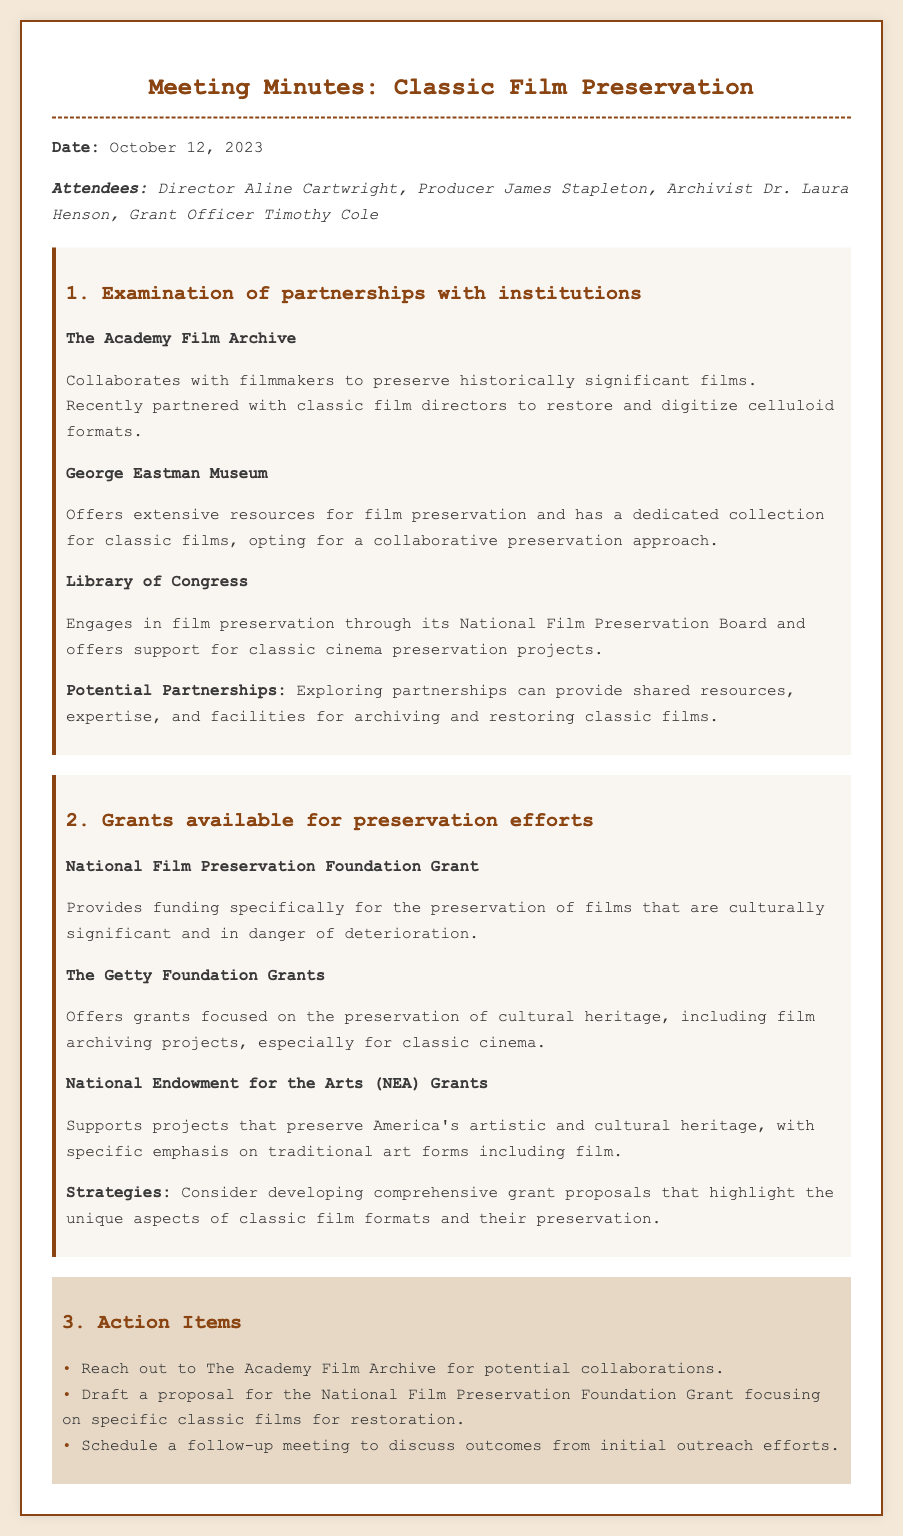What is the date of the meeting? The date of the meeting is specified at the top of the document.
Answer: October 12, 2023 Who is the archivist present at the meeting? The names of attendees are listed in the document, including their roles.
Answer: Dr. Laura Henson What institution collaborates with filmmakers to preserve historically significant films? This information is under the examination of partnerships with institutions section.
Answer: The Academy Film Archive What grant provides funding for the preservation of culturally significant films? The grants available for preservation efforts section lists various grants focused on preservation.
Answer: National Film Preservation Foundation Grant Which institution has a collection dedicated to classic films? The document specifies institutions with dedicated collections for classic films.
Answer: George Eastman Museum What is one strategy mentioned for grant proposals? The strategies section provides ideas for developing grant proposals.
Answer: Highlight the unique aspects of classic film formats What action item involves The Academy Film Archive? The action items list specific tasks to be accomplished after the meeting.
Answer: Reach out to The Academy Film Archive for potential collaborations How many potential grants are mentioned in the document? The grants available for preservation efforts section mentions several grants.
Answer: Three 